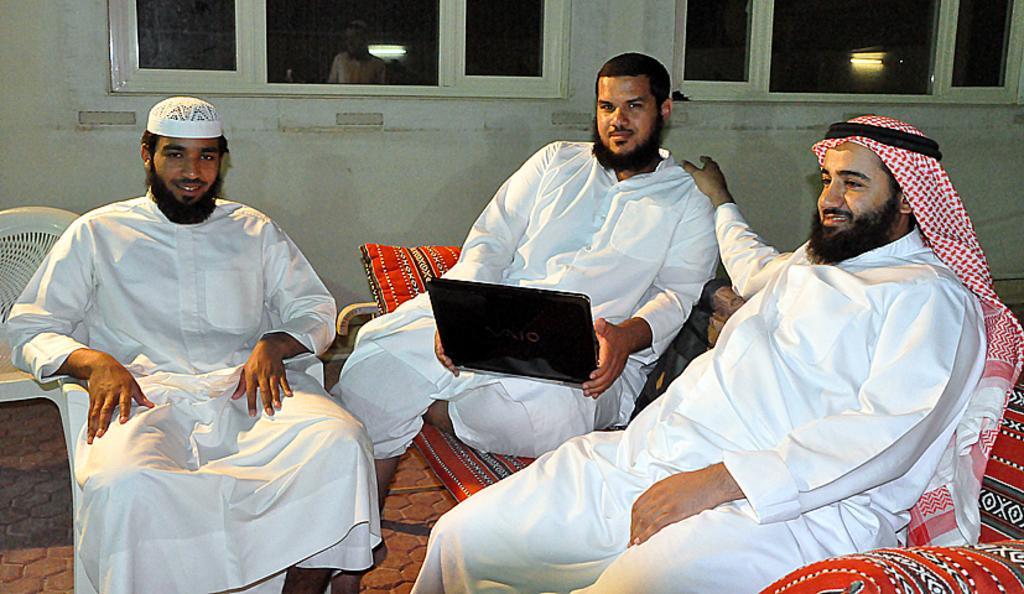Can you describe this image briefly? In the image we can see three men sitting wearing clothes and they are smiling. One man is holding a laptop and here we can see the sofa, chairs, floor and the wall. We can even see the windows and we can see the reflection of the lights on the window.  